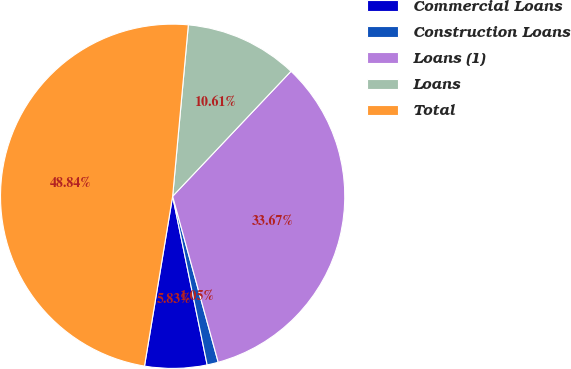Convert chart. <chart><loc_0><loc_0><loc_500><loc_500><pie_chart><fcel>Commercial Loans<fcel>Construction Loans<fcel>Loans (1)<fcel>Loans<fcel>Total<nl><fcel>5.83%<fcel>1.05%<fcel>33.67%<fcel>10.61%<fcel>48.84%<nl></chart> 